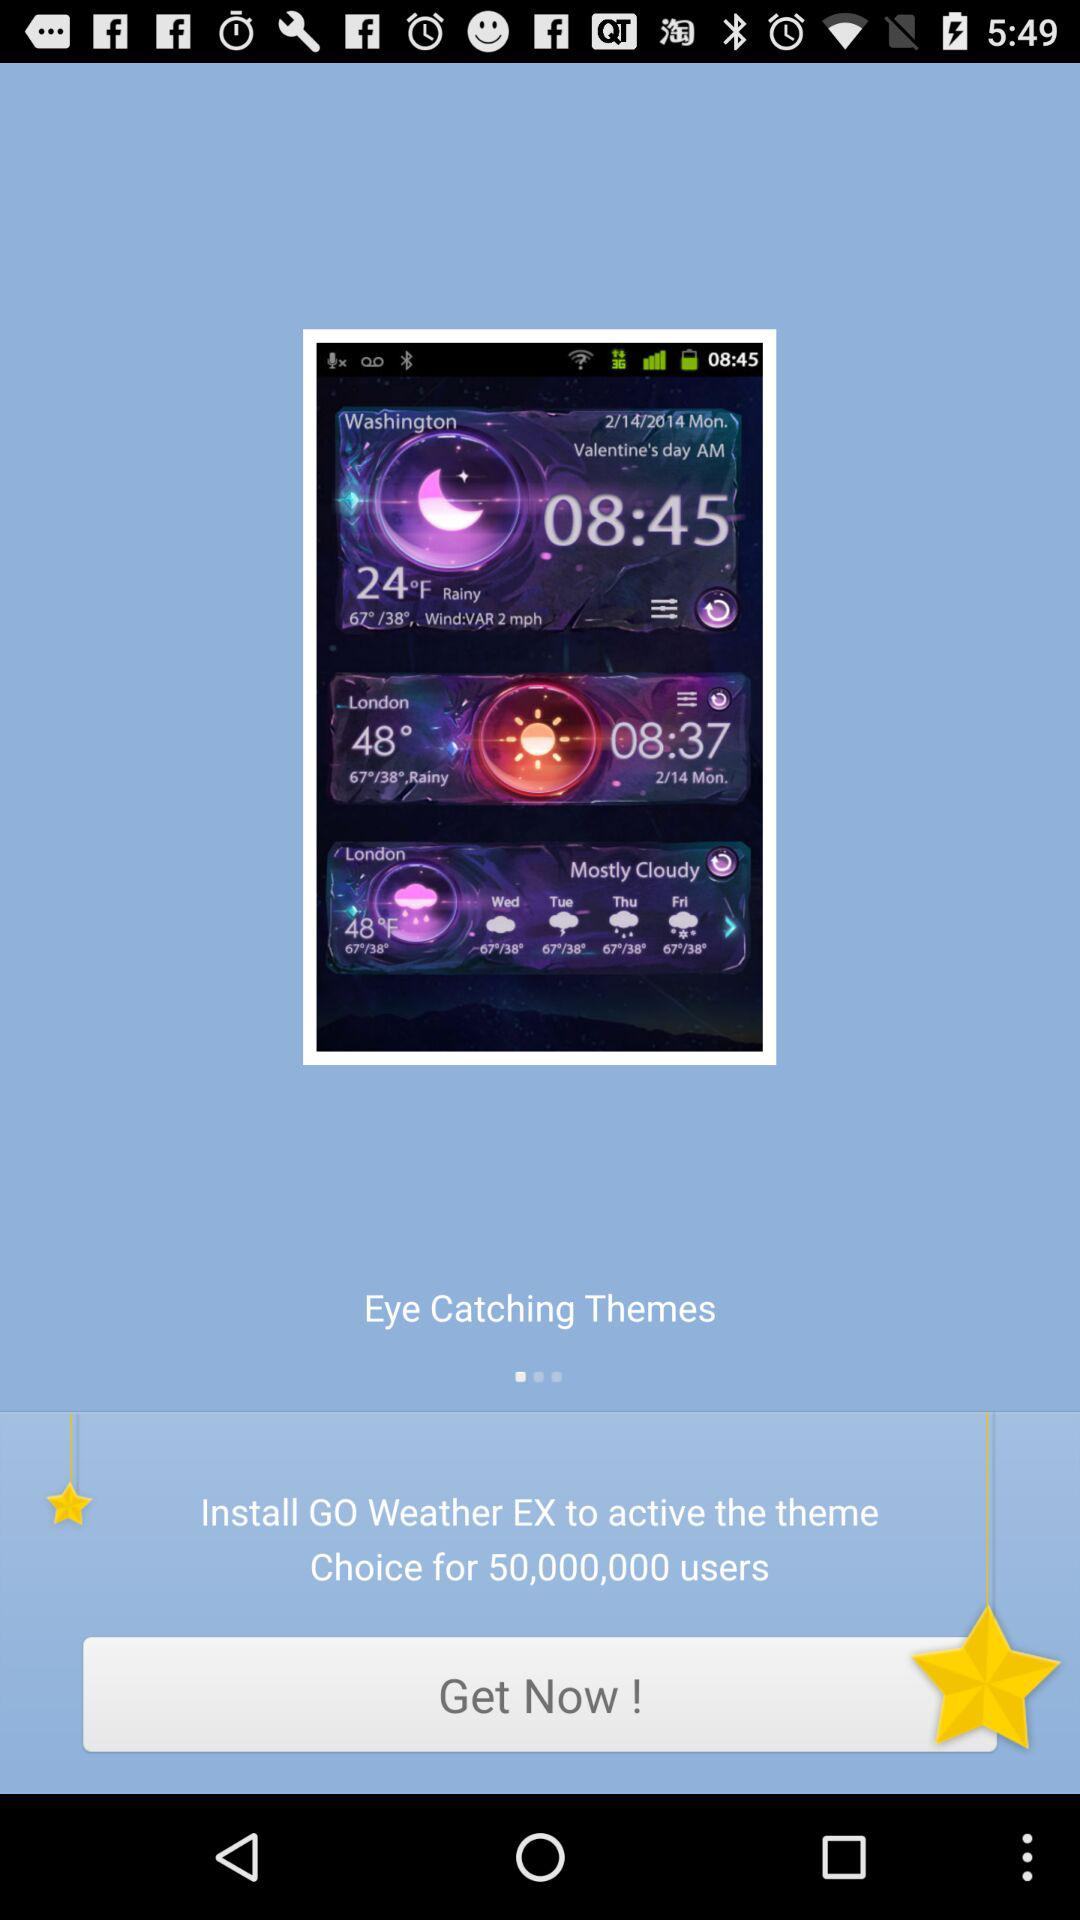How many users are displayed? The number of displayed users is 50,000,000. 